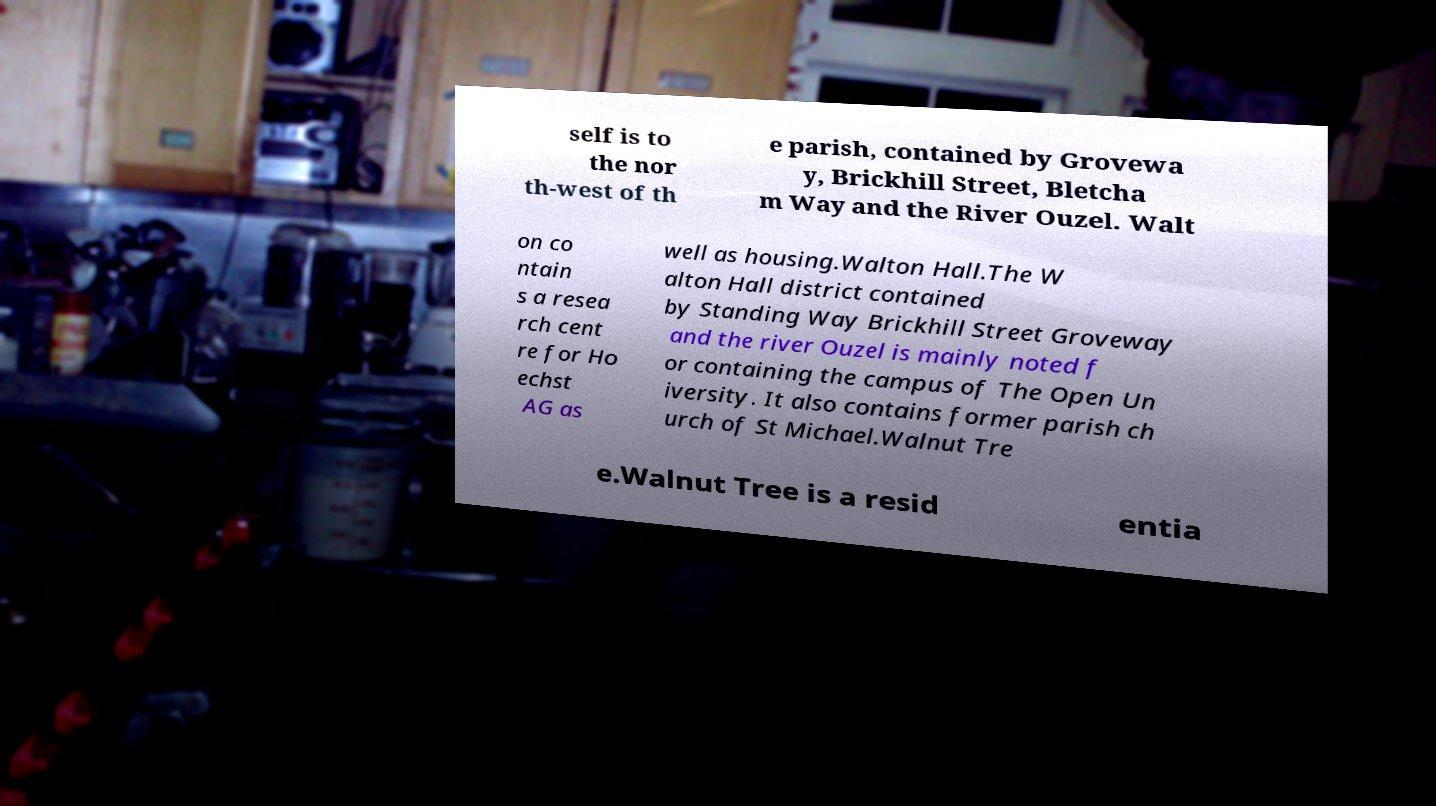Can you read and provide the text displayed in the image?This photo seems to have some interesting text. Can you extract and type it out for me? self is to the nor th-west of th e parish, contained by Grovewa y, Brickhill Street, Bletcha m Way and the River Ouzel. Walt on co ntain s a resea rch cent re for Ho echst AG as well as housing.Walton Hall.The W alton Hall district contained by Standing Way Brickhill Street Groveway and the river Ouzel is mainly noted f or containing the campus of The Open Un iversity. It also contains former parish ch urch of St Michael.Walnut Tre e.Walnut Tree is a resid entia 